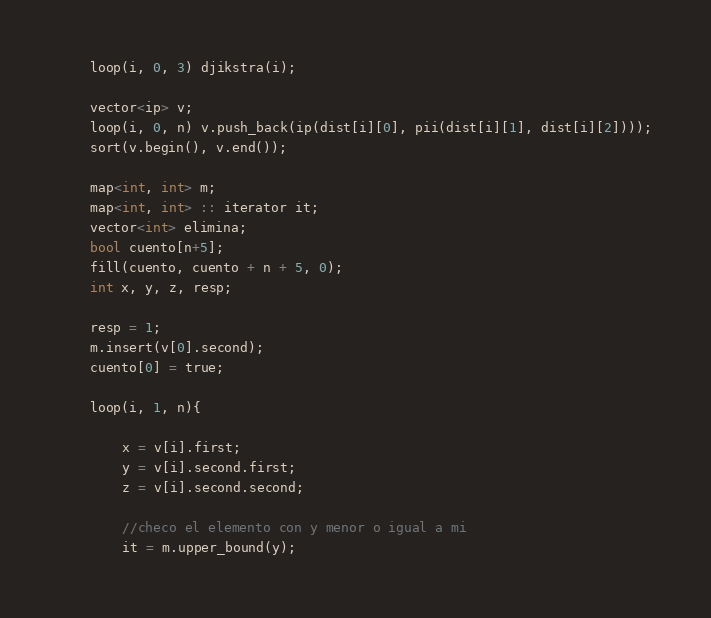<code> <loc_0><loc_0><loc_500><loc_500><_C++_>    loop(i, 0, 3) djikstra(i);
 
    vector<ip> v;
    loop(i, 0, n) v.push_back(ip(dist[i][0], pii(dist[i][1], dist[i][2])));
    sort(v.begin(), v.end());
    
    map<int, int> m;
    map<int, int> :: iterator it;
    vector<int> elimina;
    bool cuento[n+5];
    fill(cuento, cuento + n + 5, 0);
    int x, y, z, resp;
 
    resp = 1;
    m.insert(v[0].second);
    cuento[0] = true;
 
    loop(i, 1, n){
        
        x = v[i].first;
        y = v[i].second.first;
        z = v[i].second.second;
 
        //checo el elemento con y menor o igual a mi 
        it = m.upper_bound(y); </code> 